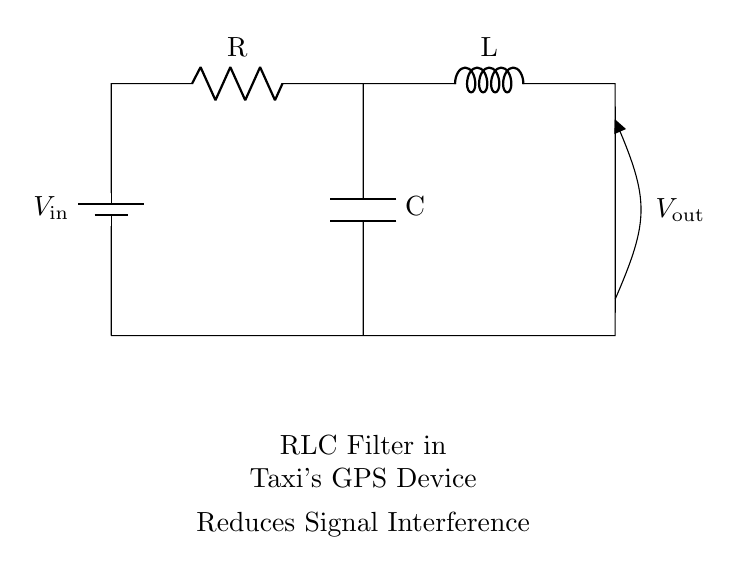What are the components in this circuit? The components visible in the circuit diagram include a resistor, an inductor, and a capacitor, which are arranged to form an RLC filter. These components are essential for filtering the GPS signals and reducing interference.
Answer: Resistor, Inductor, Capacitor What does the battery supply in this circuit? The circuit shows a battery labeled as V in which is supplying the input voltage to the RLC filter. This voltage is crucial for the operation of the circuit as it provides the necessary electrical energy for filtering signals.
Answer: Input voltage What is the purpose of this circuit? This circuit is designed to reduce signal interference in a taxi's GPS device. RLC filters are commonly used to enhance signal clarity by removing unwanted frequencies, thus improving GPS performance.
Answer: Reduce signal interference What type of filter is represented in this circuit? The filter formed by the resistor, inductor, and capacitor is categorized as an RLC filter. RLC filters can be either low-pass, high-pass, or band-pass depending on the configuration and value of the components used.
Answer: RLC filter How does this circuit affect the GPS signal received? The RLC filter allows certain frequencies of the GPS signal to pass while attenuating others, effectively reducing noise and interference, and improving the overall quality and reliability of the GPS readings in the taxi.
Answer: Improves GPS signal quality What can be inferred about the circuit's output voltage? The output voltage, indicated as V out, is essential for understanding how the circuit modifies the input signal. Given that RLC circuits typically alter the voltage based on frequency, we can infer V out will vary with the signal characteristics being filtered.
Answer: V out varies with frequency 